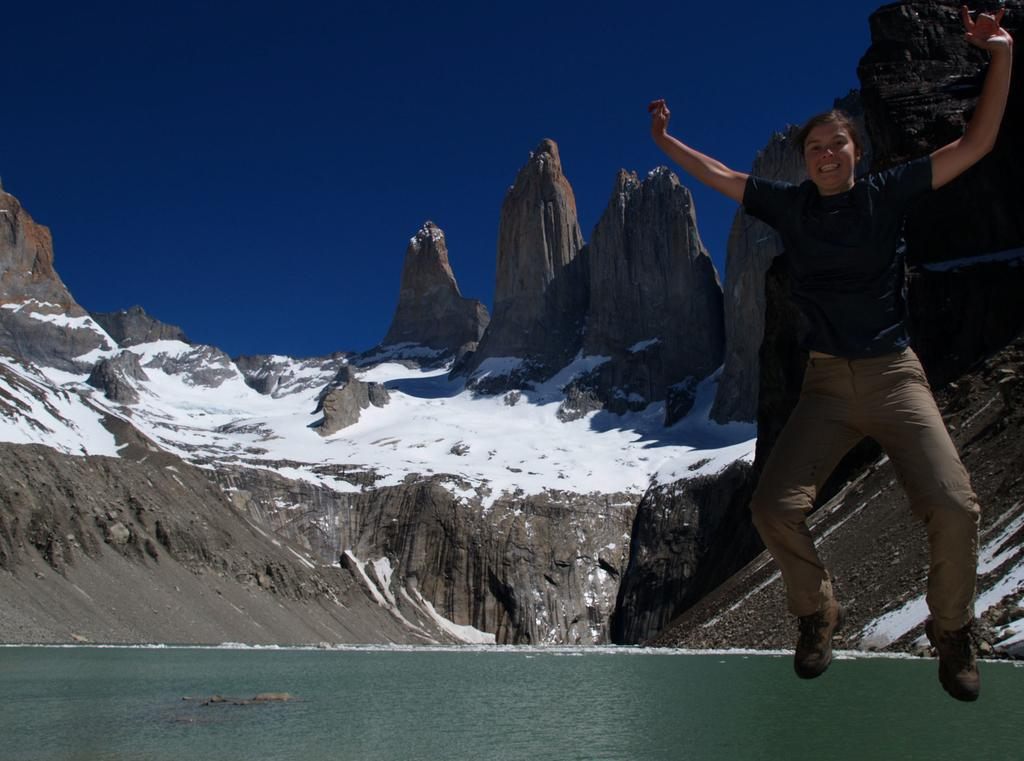What is the person in the image doing? There is a person in the air in the image, which suggests they might be skydiving or paragliding. What can be seen in the distance behind the person? There is water and mountains visible in the background of the image. What is the weather like in the image? The presence of snow and a blue sky suggests that it is cold and likely sunny. What color is the sky in the image? The sky is blue in color. What type of creature is reciting a verse in the image? There is no creature or verse present in the image; it features a person in the air with a background of water, mountains, snow, and a blue sky. 